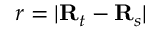<formula> <loc_0><loc_0><loc_500><loc_500>r = | \mathbf R _ { t } - \mathbf R _ { s } |</formula> 